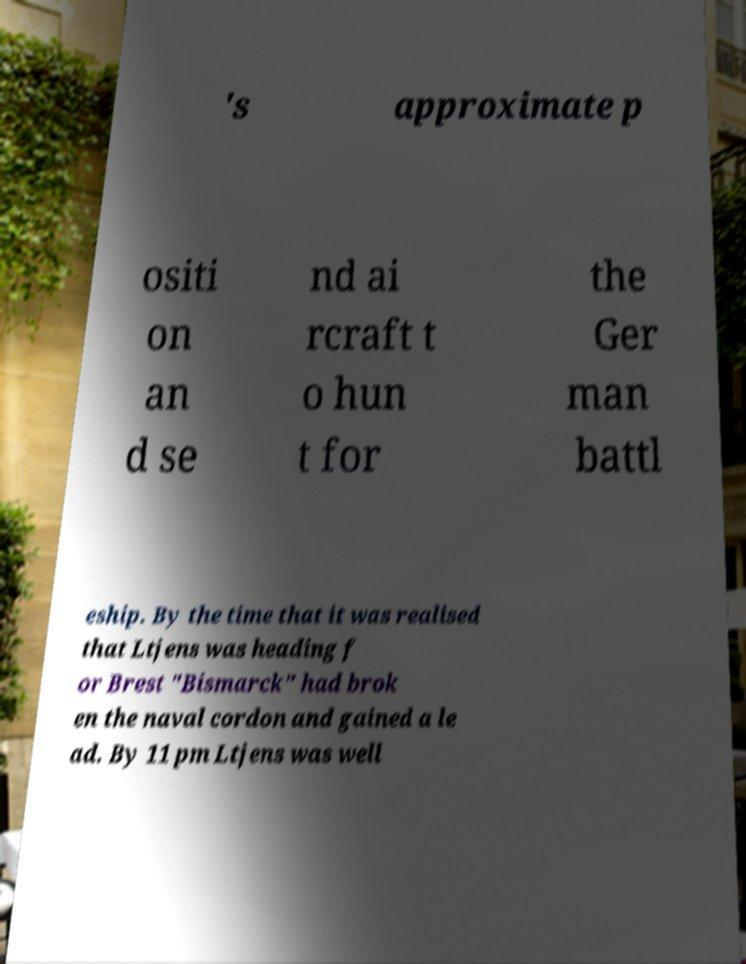Can you accurately transcribe the text from the provided image for me? 's approximate p ositi on an d se nd ai rcraft t o hun t for the Ger man battl eship. By the time that it was realised that Ltjens was heading f or Brest "Bismarck" had brok en the naval cordon and gained a le ad. By 11 pm Ltjens was well 